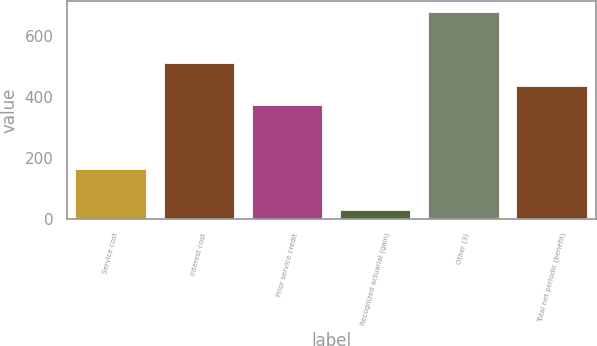<chart> <loc_0><loc_0><loc_500><loc_500><bar_chart><fcel>Service cost<fcel>Interest cost<fcel>Prior service credit<fcel>Recognized actuarial (gain)<fcel>Other (3)<fcel>Total net periodic (benefit)<nl><fcel>163<fcel>512<fcel>372<fcel>30<fcel>679<fcel>436.9<nl></chart> 